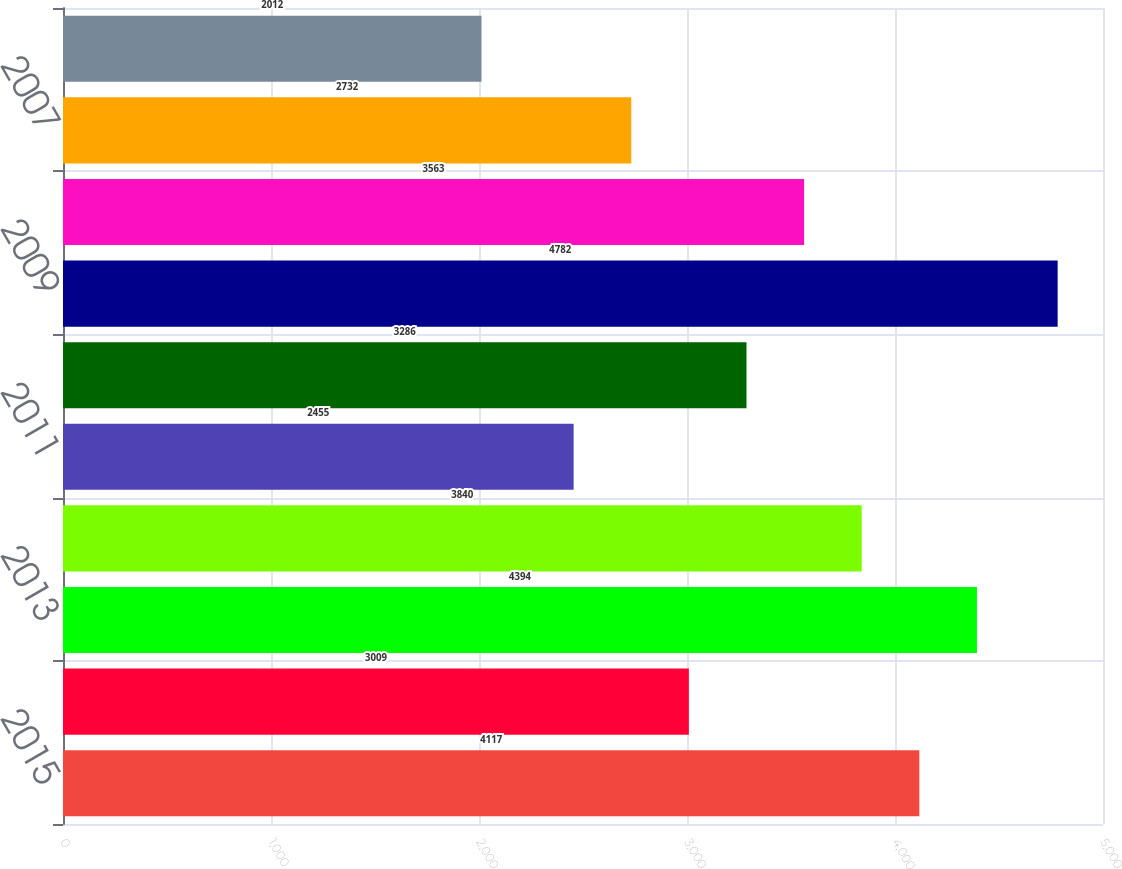Convert chart. <chart><loc_0><loc_0><loc_500><loc_500><bar_chart><fcel>2015<fcel>2014<fcel>2013<fcel>2012<fcel>2011<fcel>2010<fcel>2009<fcel>2008<fcel>2007<fcel>2006<nl><fcel>4117<fcel>3009<fcel>4394<fcel>3840<fcel>2455<fcel>3286<fcel>4782<fcel>3563<fcel>2732<fcel>2012<nl></chart> 